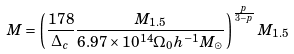Convert formula to latex. <formula><loc_0><loc_0><loc_500><loc_500>M = \left ( \frac { 1 7 8 } { \Delta _ { c } } \frac { M _ { 1 . 5 } } { 6 . 9 7 \times 1 0 ^ { 1 4 } \Omega _ { 0 } h ^ { - 1 } M _ { \odot } } \right ) ^ { \frac { p } { 3 - p } } M _ { 1 . 5 }</formula> 